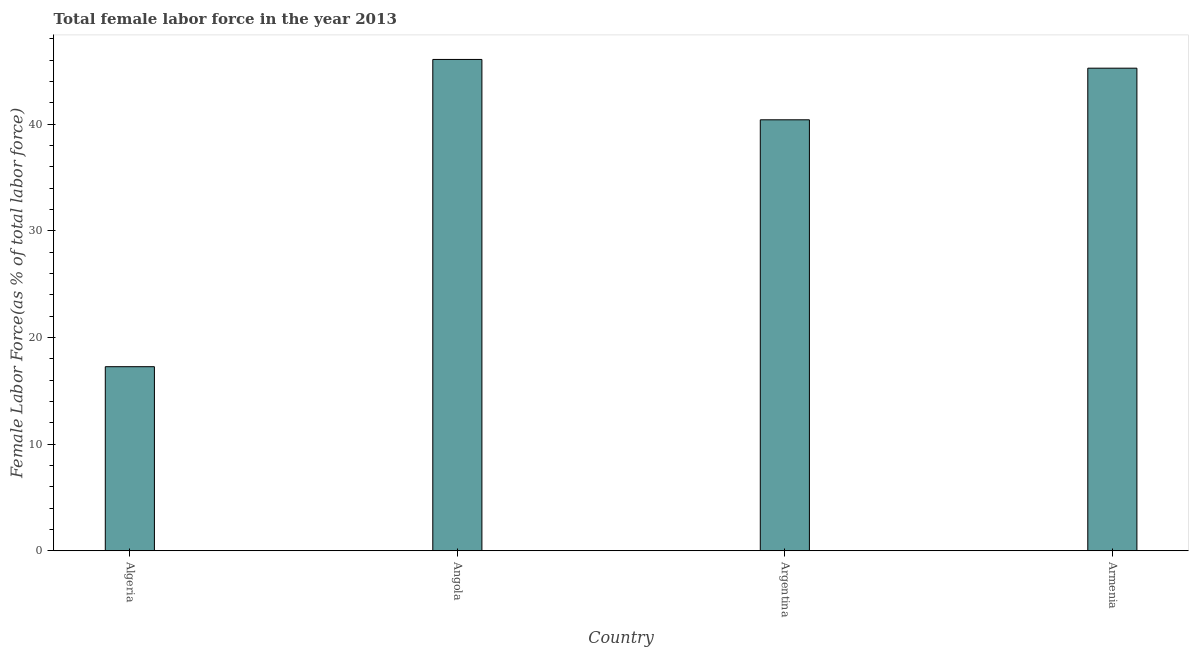Does the graph contain any zero values?
Provide a short and direct response. No. Does the graph contain grids?
Offer a very short reply. No. What is the title of the graph?
Offer a terse response. Total female labor force in the year 2013. What is the label or title of the Y-axis?
Provide a short and direct response. Female Labor Force(as % of total labor force). What is the total female labor force in Argentina?
Your response must be concise. 40.42. Across all countries, what is the maximum total female labor force?
Your answer should be compact. 46.08. Across all countries, what is the minimum total female labor force?
Your answer should be very brief. 17.26. In which country was the total female labor force maximum?
Make the answer very short. Angola. In which country was the total female labor force minimum?
Your response must be concise. Algeria. What is the sum of the total female labor force?
Offer a terse response. 149.03. What is the difference between the total female labor force in Angola and Armenia?
Make the answer very short. 0.82. What is the average total female labor force per country?
Your answer should be very brief. 37.26. What is the median total female labor force?
Your answer should be compact. 42.84. In how many countries, is the total female labor force greater than 34 %?
Provide a short and direct response. 3. Is the total female labor force in Algeria less than that in Armenia?
Ensure brevity in your answer.  Yes. Is the difference between the total female labor force in Argentina and Armenia greater than the difference between any two countries?
Your response must be concise. No. What is the difference between the highest and the second highest total female labor force?
Offer a terse response. 0.82. Is the sum of the total female labor force in Angola and Armenia greater than the maximum total female labor force across all countries?
Give a very brief answer. Yes. What is the difference between the highest and the lowest total female labor force?
Your response must be concise. 28.82. In how many countries, is the total female labor force greater than the average total female labor force taken over all countries?
Offer a very short reply. 3. How many bars are there?
Make the answer very short. 4. How many countries are there in the graph?
Provide a succinct answer. 4. What is the difference between two consecutive major ticks on the Y-axis?
Your answer should be very brief. 10. Are the values on the major ticks of Y-axis written in scientific E-notation?
Provide a short and direct response. No. What is the Female Labor Force(as % of total labor force) in Algeria?
Your response must be concise. 17.26. What is the Female Labor Force(as % of total labor force) in Angola?
Provide a short and direct response. 46.08. What is the Female Labor Force(as % of total labor force) of Argentina?
Offer a very short reply. 40.42. What is the Female Labor Force(as % of total labor force) of Armenia?
Provide a short and direct response. 45.26. What is the difference between the Female Labor Force(as % of total labor force) in Algeria and Angola?
Your answer should be very brief. -28.82. What is the difference between the Female Labor Force(as % of total labor force) in Algeria and Argentina?
Your answer should be compact. -23.16. What is the difference between the Female Labor Force(as % of total labor force) in Algeria and Armenia?
Offer a very short reply. -28. What is the difference between the Female Labor Force(as % of total labor force) in Angola and Argentina?
Give a very brief answer. 5.66. What is the difference between the Female Labor Force(as % of total labor force) in Angola and Armenia?
Keep it short and to the point. 0.82. What is the difference between the Female Labor Force(as % of total labor force) in Argentina and Armenia?
Offer a very short reply. -4.84. What is the ratio of the Female Labor Force(as % of total labor force) in Algeria to that in Angola?
Give a very brief answer. 0.38. What is the ratio of the Female Labor Force(as % of total labor force) in Algeria to that in Argentina?
Your answer should be very brief. 0.43. What is the ratio of the Female Labor Force(as % of total labor force) in Algeria to that in Armenia?
Your answer should be compact. 0.38. What is the ratio of the Female Labor Force(as % of total labor force) in Angola to that in Argentina?
Your response must be concise. 1.14. What is the ratio of the Female Labor Force(as % of total labor force) in Angola to that in Armenia?
Provide a succinct answer. 1.02. What is the ratio of the Female Labor Force(as % of total labor force) in Argentina to that in Armenia?
Ensure brevity in your answer.  0.89. 